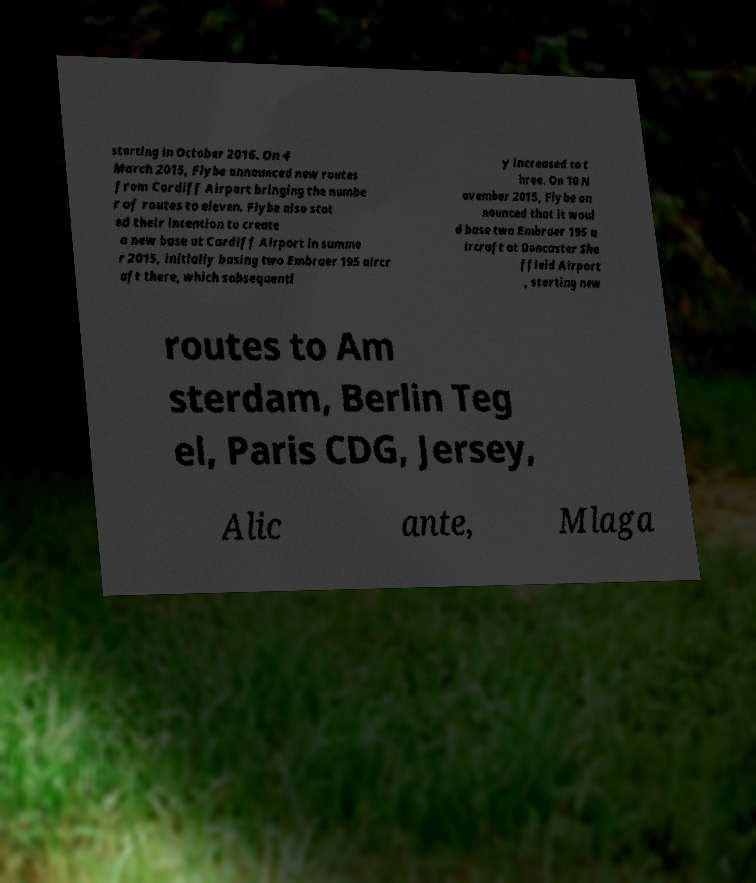Could you extract and type out the text from this image? starting in October 2016. On 4 March 2015, Flybe announced new routes from Cardiff Airport bringing the numbe r of routes to eleven. Flybe also stat ed their intention to create a new base at Cardiff Airport in summe r 2015, initially basing two Embraer 195 aircr aft there, which subsequentl y increased to t hree. On 10 N ovember 2015, Flybe an nounced that it woul d base two Embraer 195 a ircraft at Doncaster She ffield Airport , starting new routes to Am sterdam, Berlin Teg el, Paris CDG, Jersey, Alic ante, Mlaga 